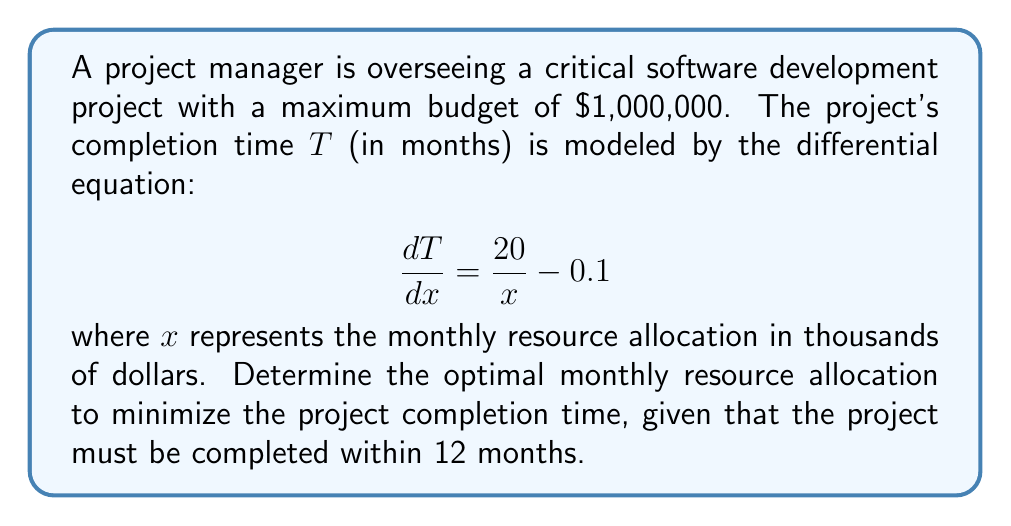Help me with this question. To solve this problem, we need to follow these steps:

1) First, we need to find the general solution to the differential equation:

   $$\frac{dT}{dx} = \frac{20}{x} - 0.1$$

   Integrating both sides:

   $$T = 20\ln|x| - 0.1x + C$$

2) To minimize T, we need to find where $\frac{dT}{dx} = 0$:

   $$\frac{dT}{dx} = \frac{20}{x} - 0.1 = 0$$

   Solving this:

   $$\frac{20}{x} = 0.1$$
   $$x = 200$$

3) This means the optimal monthly resource allocation is $200,000.

4) Now, we need to check if this allocation meets the constraints:

   - Monthly allocation: $200,000 < $1,000,000 (maximum budget), so this is okay.
   - Total project duration: We need to solve for C in the general solution using the constraint that T = 12 when x = 200:

     $$12 = 20\ln|200| - 0.1(200) + C$$
     $$C = 12 - 20\ln|200| + 20 = 12 - 105.966 + 20 = -73.966$$

   - Therefore, the specific solution is:

     $$T = 20\ln|x| - 0.1x - 73.966$$

5) We can verify that this indeed gives T = 12 when x = 200, meeting our constraint.

Thus, the optimal monthly resource allocation of $200,000 minimizes the project completion time while meeting all constraints.
Answer: The optimal monthly resource allocation to minimize the project completion time is $200,000. 